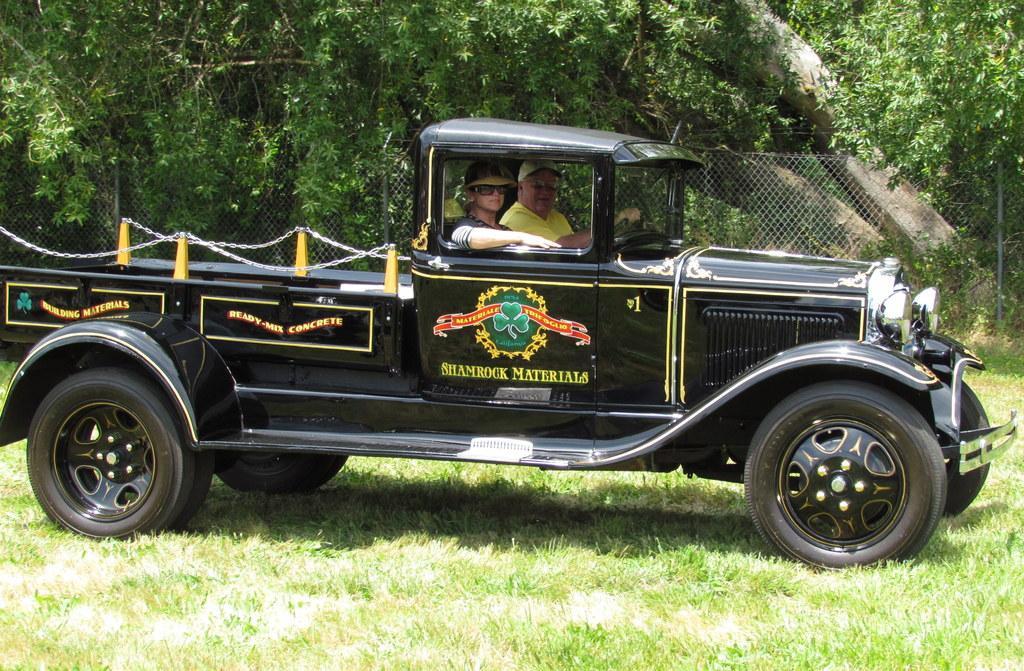Please provide a concise description of this image. In the foreground of this picture, there is a black color truck where two men sitting inside is on the grass. In the background, there is a fencing and trees. 